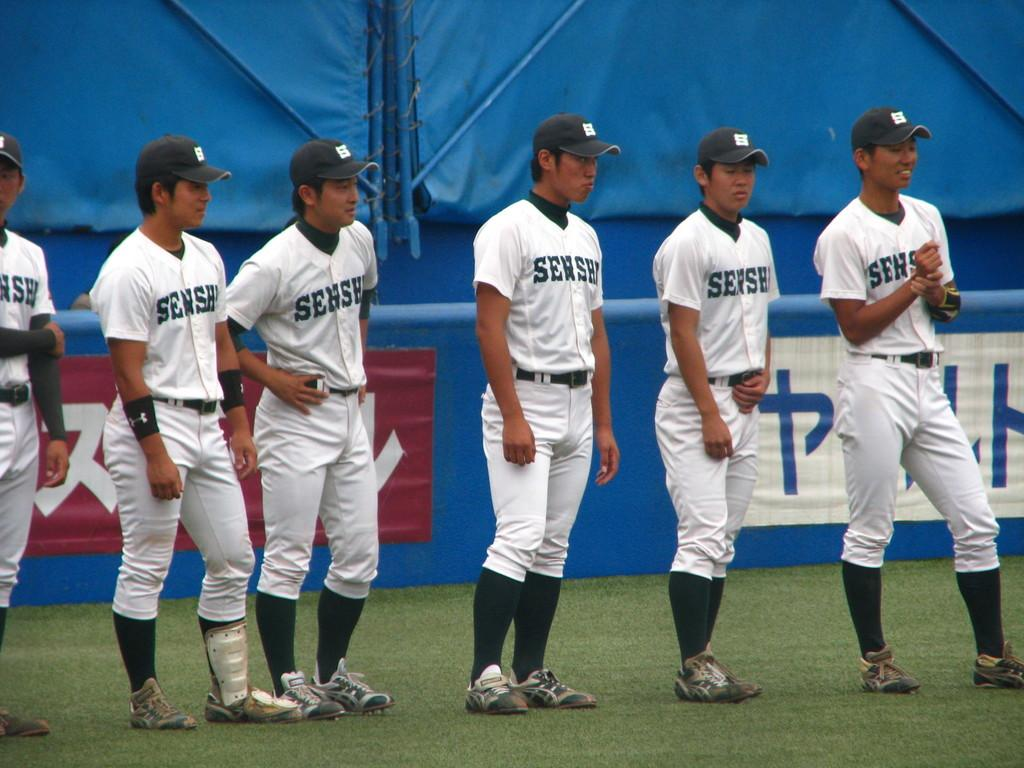<image>
Offer a succinct explanation of the picture presented. A baseball team stands in line wearing white uniforms with Sensh on them. 